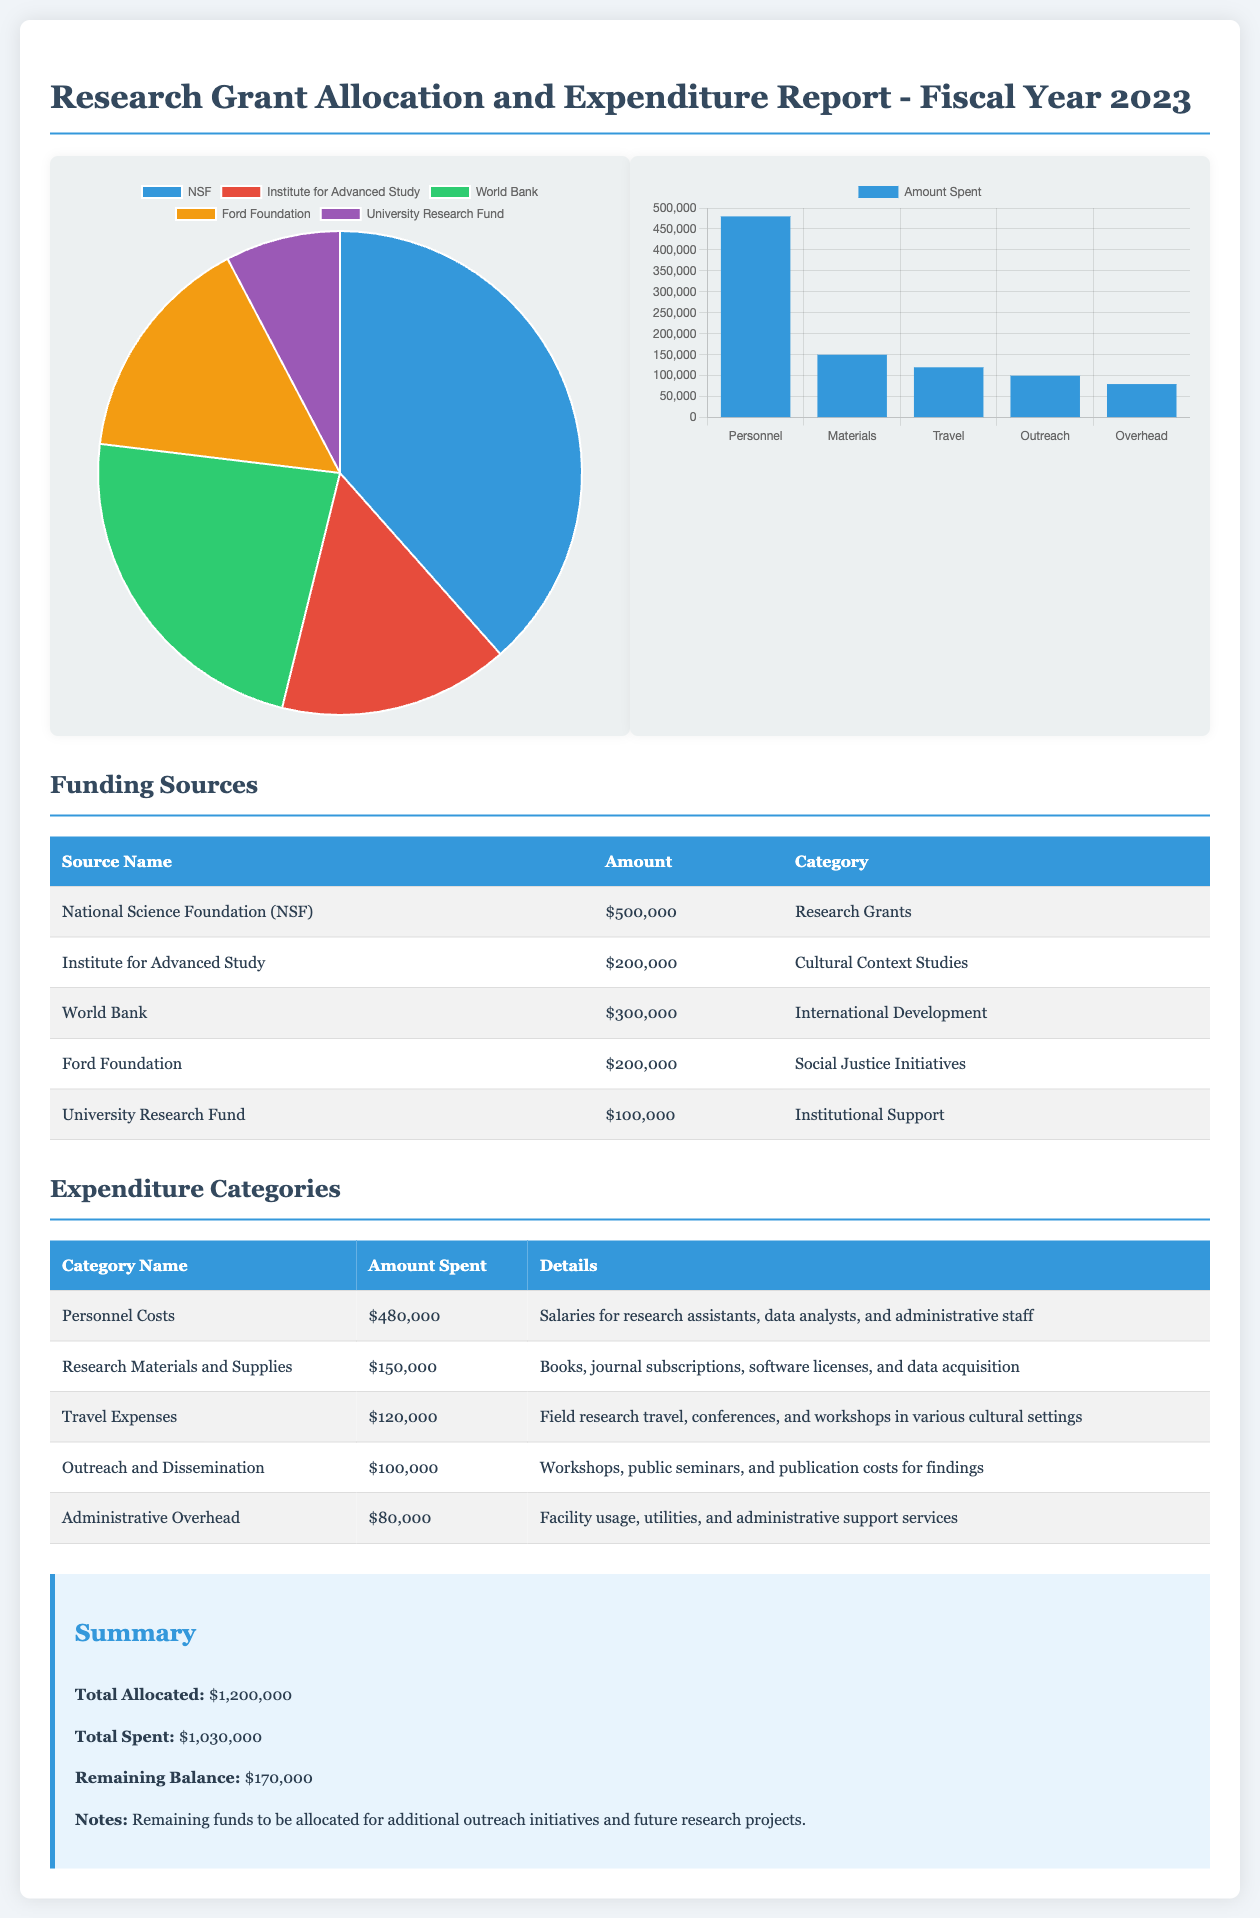what is the total allocated amount? The total allocated amount is stated in the summary section of the document. It is the sum total of all funding sources.
Answer: $1,200,000 which source provided the highest funding? This information can be found in the Funding Sources table where amounts are listed next to source names.
Answer: National Science Foundation (NSF) how much was spent on travel expenses? The amount spent on travel expenses is detailed in the Expenditure Categories table.
Answer: $120,000 what is the remaining balance of the grant? The remaining balance is given in the summary section and calculated by subtracting the total spent from the total allocated.
Answer: $170,000 which category had the highest expenditure? The Expenditure Categories table lists various expenditure categories and their amounts spent.
Answer: Personnel Costs how much was allocated from the Ford Foundation? The allocated amount from the Ford Foundation is mentioned in the Funding Sources table.
Answer: $200,000 what percentage of the total allocation was spent on personnel costs? This requires calculating the percentage based on the totals provided in the summary and expenditure sections.
Answer: 40% how many funding sources are listed in the document? The Funding Sources table shows the total number of sources.
Answer: 5 what type of costs does 'Research Materials and Supplies' include? The details for categories are provided in the Expenditure Categories table, specifying what is included.
Answer: Books, journal subscriptions, software licenses, and data acquisition 